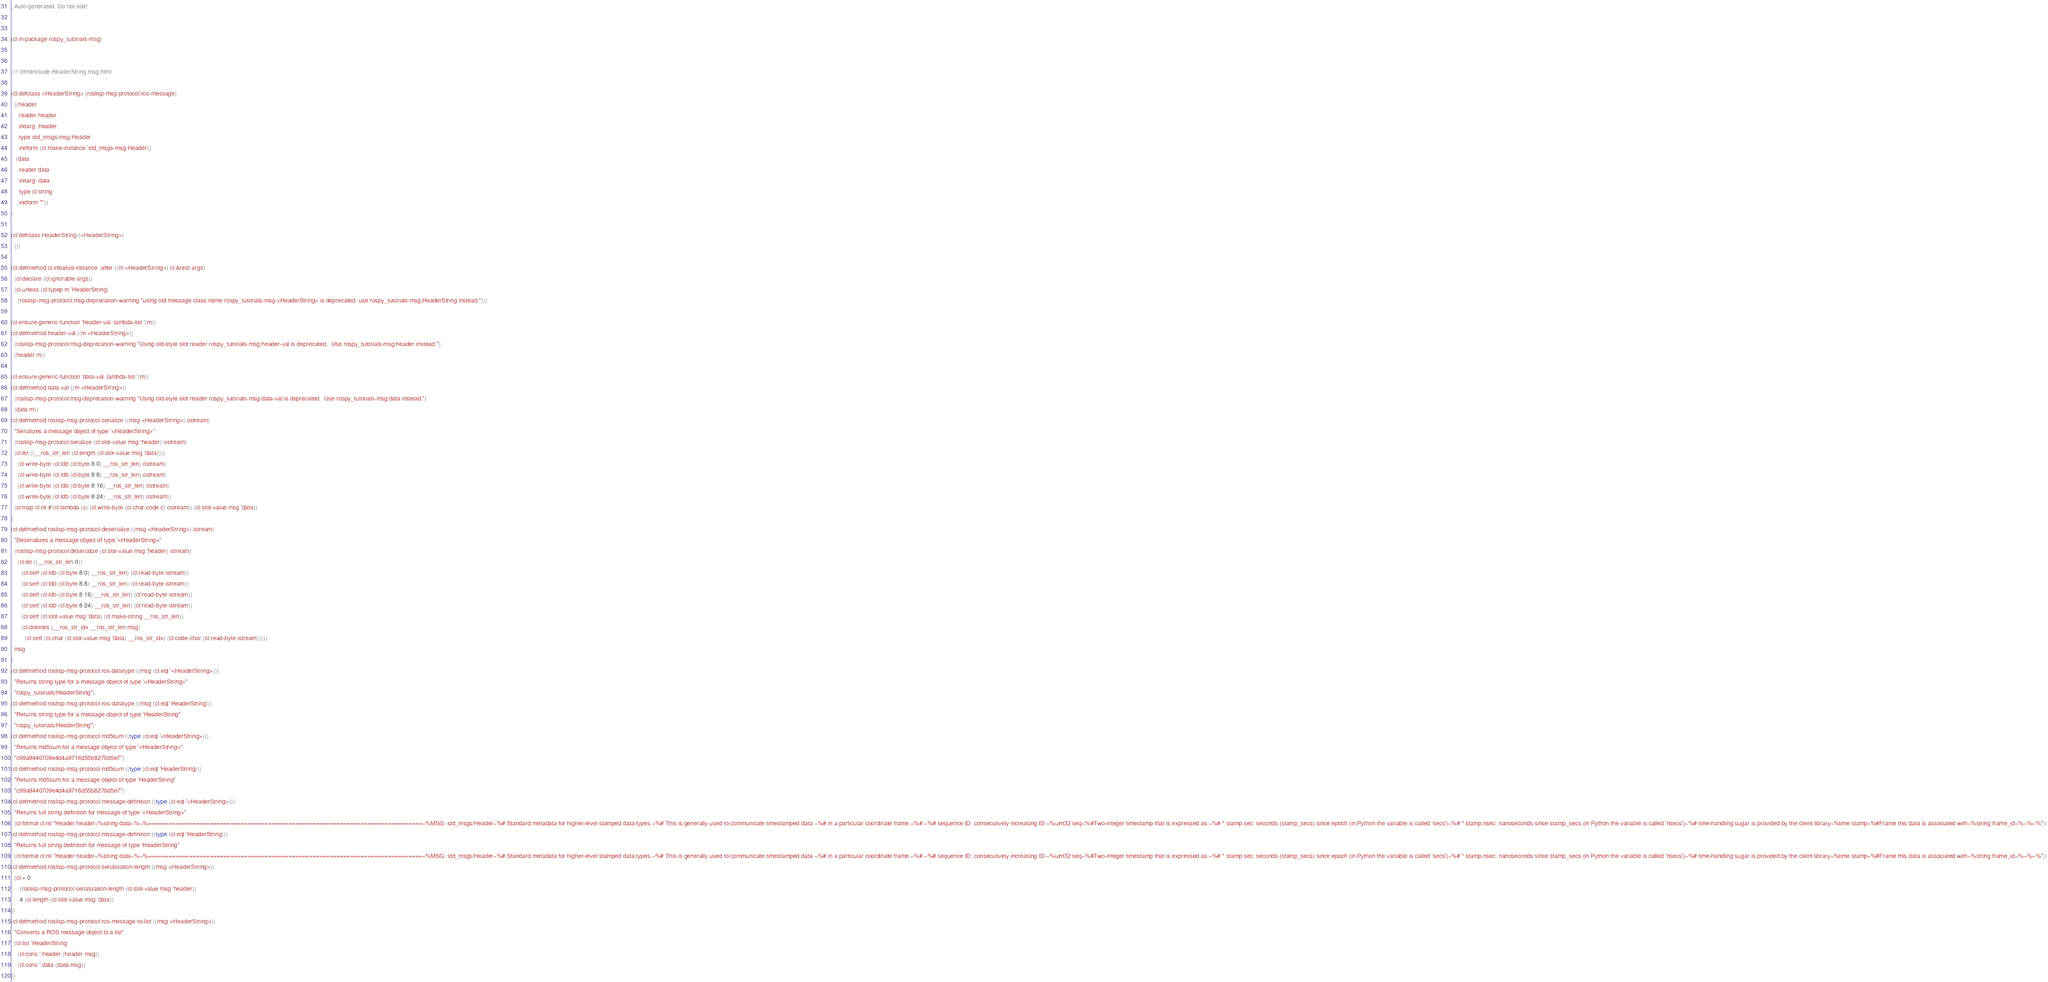Convert code to text. <code><loc_0><loc_0><loc_500><loc_500><_Lisp_>; Auto-generated. Do not edit!


(cl:in-package rospy_tutorials-msg)


;//! \htmlinclude HeaderString.msg.html

(cl:defclass <HeaderString> (roslisp-msg-protocol:ros-message)
  ((header
    :reader header
    :initarg :header
    :type std_msgs-msg:Header
    :initform (cl:make-instance 'std_msgs-msg:Header))
   (data
    :reader data
    :initarg :data
    :type cl:string
    :initform ""))
)

(cl:defclass HeaderString (<HeaderString>)
  ())

(cl:defmethod cl:initialize-instance :after ((m <HeaderString>) cl:&rest args)
  (cl:declare (cl:ignorable args))
  (cl:unless (cl:typep m 'HeaderString)
    (roslisp-msg-protocol:msg-deprecation-warning "using old message class name rospy_tutorials-msg:<HeaderString> is deprecated: use rospy_tutorials-msg:HeaderString instead.")))

(cl:ensure-generic-function 'header-val :lambda-list '(m))
(cl:defmethod header-val ((m <HeaderString>))
  (roslisp-msg-protocol:msg-deprecation-warning "Using old-style slot reader rospy_tutorials-msg:header-val is deprecated.  Use rospy_tutorials-msg:header instead.")
  (header m))

(cl:ensure-generic-function 'data-val :lambda-list '(m))
(cl:defmethod data-val ((m <HeaderString>))
  (roslisp-msg-protocol:msg-deprecation-warning "Using old-style slot reader rospy_tutorials-msg:data-val is deprecated.  Use rospy_tutorials-msg:data instead.")
  (data m))
(cl:defmethod roslisp-msg-protocol:serialize ((msg <HeaderString>) ostream)
  "Serializes a message object of type '<HeaderString>"
  (roslisp-msg-protocol:serialize (cl:slot-value msg 'header) ostream)
  (cl:let ((__ros_str_len (cl:length (cl:slot-value msg 'data))))
    (cl:write-byte (cl:ldb (cl:byte 8 0) __ros_str_len) ostream)
    (cl:write-byte (cl:ldb (cl:byte 8 8) __ros_str_len) ostream)
    (cl:write-byte (cl:ldb (cl:byte 8 16) __ros_str_len) ostream)
    (cl:write-byte (cl:ldb (cl:byte 8 24) __ros_str_len) ostream))
  (cl:map cl:nil #'(cl:lambda (c) (cl:write-byte (cl:char-code c) ostream)) (cl:slot-value msg 'data))
)
(cl:defmethod roslisp-msg-protocol:deserialize ((msg <HeaderString>) istream)
  "Deserializes a message object of type '<HeaderString>"
  (roslisp-msg-protocol:deserialize (cl:slot-value msg 'header) istream)
    (cl:let ((__ros_str_len 0))
      (cl:setf (cl:ldb (cl:byte 8 0) __ros_str_len) (cl:read-byte istream))
      (cl:setf (cl:ldb (cl:byte 8 8) __ros_str_len) (cl:read-byte istream))
      (cl:setf (cl:ldb (cl:byte 8 16) __ros_str_len) (cl:read-byte istream))
      (cl:setf (cl:ldb (cl:byte 8 24) __ros_str_len) (cl:read-byte istream))
      (cl:setf (cl:slot-value msg 'data) (cl:make-string __ros_str_len))
      (cl:dotimes (__ros_str_idx __ros_str_len msg)
        (cl:setf (cl:char (cl:slot-value msg 'data) __ros_str_idx) (cl:code-char (cl:read-byte istream)))))
  msg
)
(cl:defmethod roslisp-msg-protocol:ros-datatype ((msg (cl:eql '<HeaderString>)))
  "Returns string type for a message object of type '<HeaderString>"
  "rospy_tutorials/HeaderString")
(cl:defmethod roslisp-msg-protocol:ros-datatype ((msg (cl:eql 'HeaderString)))
  "Returns string type for a message object of type 'HeaderString"
  "rospy_tutorials/HeaderString")
(cl:defmethod roslisp-msg-protocol:md5sum ((type (cl:eql '<HeaderString>)))
  "Returns md5sum for a message object of type '<HeaderString>"
  "c99a9440709e4d4a9716d55b8270d5e7")
(cl:defmethod roslisp-msg-protocol:md5sum ((type (cl:eql 'HeaderString)))
  "Returns md5sum for a message object of type 'HeaderString"
  "c99a9440709e4d4a9716d55b8270d5e7")
(cl:defmethod roslisp-msg-protocol:message-definition ((type (cl:eql '<HeaderString>)))
  "Returns full string definition for message of type '<HeaderString>"
  (cl:format cl:nil "Header header~%string data~%~%================================================================================~%MSG: std_msgs/Header~%# Standard metadata for higher-level stamped data types.~%# This is generally used to communicate timestamped data ~%# in a particular coordinate frame.~%# ~%# sequence ID: consecutively increasing ID ~%uint32 seq~%#Two-integer timestamp that is expressed as:~%# * stamp.sec: seconds (stamp_secs) since epoch (in Python the variable is called 'secs')~%# * stamp.nsec: nanoseconds since stamp_secs (in Python the variable is called 'nsecs')~%# time-handling sugar is provided by the client library~%time stamp~%#Frame this data is associated with~%string frame_id~%~%~%"))
(cl:defmethod roslisp-msg-protocol:message-definition ((type (cl:eql 'HeaderString)))
  "Returns full string definition for message of type 'HeaderString"
  (cl:format cl:nil "Header header~%string data~%~%================================================================================~%MSG: std_msgs/Header~%# Standard metadata for higher-level stamped data types.~%# This is generally used to communicate timestamped data ~%# in a particular coordinate frame.~%# ~%# sequence ID: consecutively increasing ID ~%uint32 seq~%#Two-integer timestamp that is expressed as:~%# * stamp.sec: seconds (stamp_secs) since epoch (in Python the variable is called 'secs')~%# * stamp.nsec: nanoseconds since stamp_secs (in Python the variable is called 'nsecs')~%# time-handling sugar is provided by the client library~%time stamp~%#Frame this data is associated with~%string frame_id~%~%~%"))
(cl:defmethod roslisp-msg-protocol:serialization-length ((msg <HeaderString>))
  (cl:+ 0
     (roslisp-msg-protocol:serialization-length (cl:slot-value msg 'header))
     4 (cl:length (cl:slot-value msg 'data))
))
(cl:defmethod roslisp-msg-protocol:ros-message-to-list ((msg <HeaderString>))
  "Converts a ROS message object to a list"
  (cl:list 'HeaderString
    (cl:cons ':header (header msg))
    (cl:cons ':data (data msg))
))
</code> 